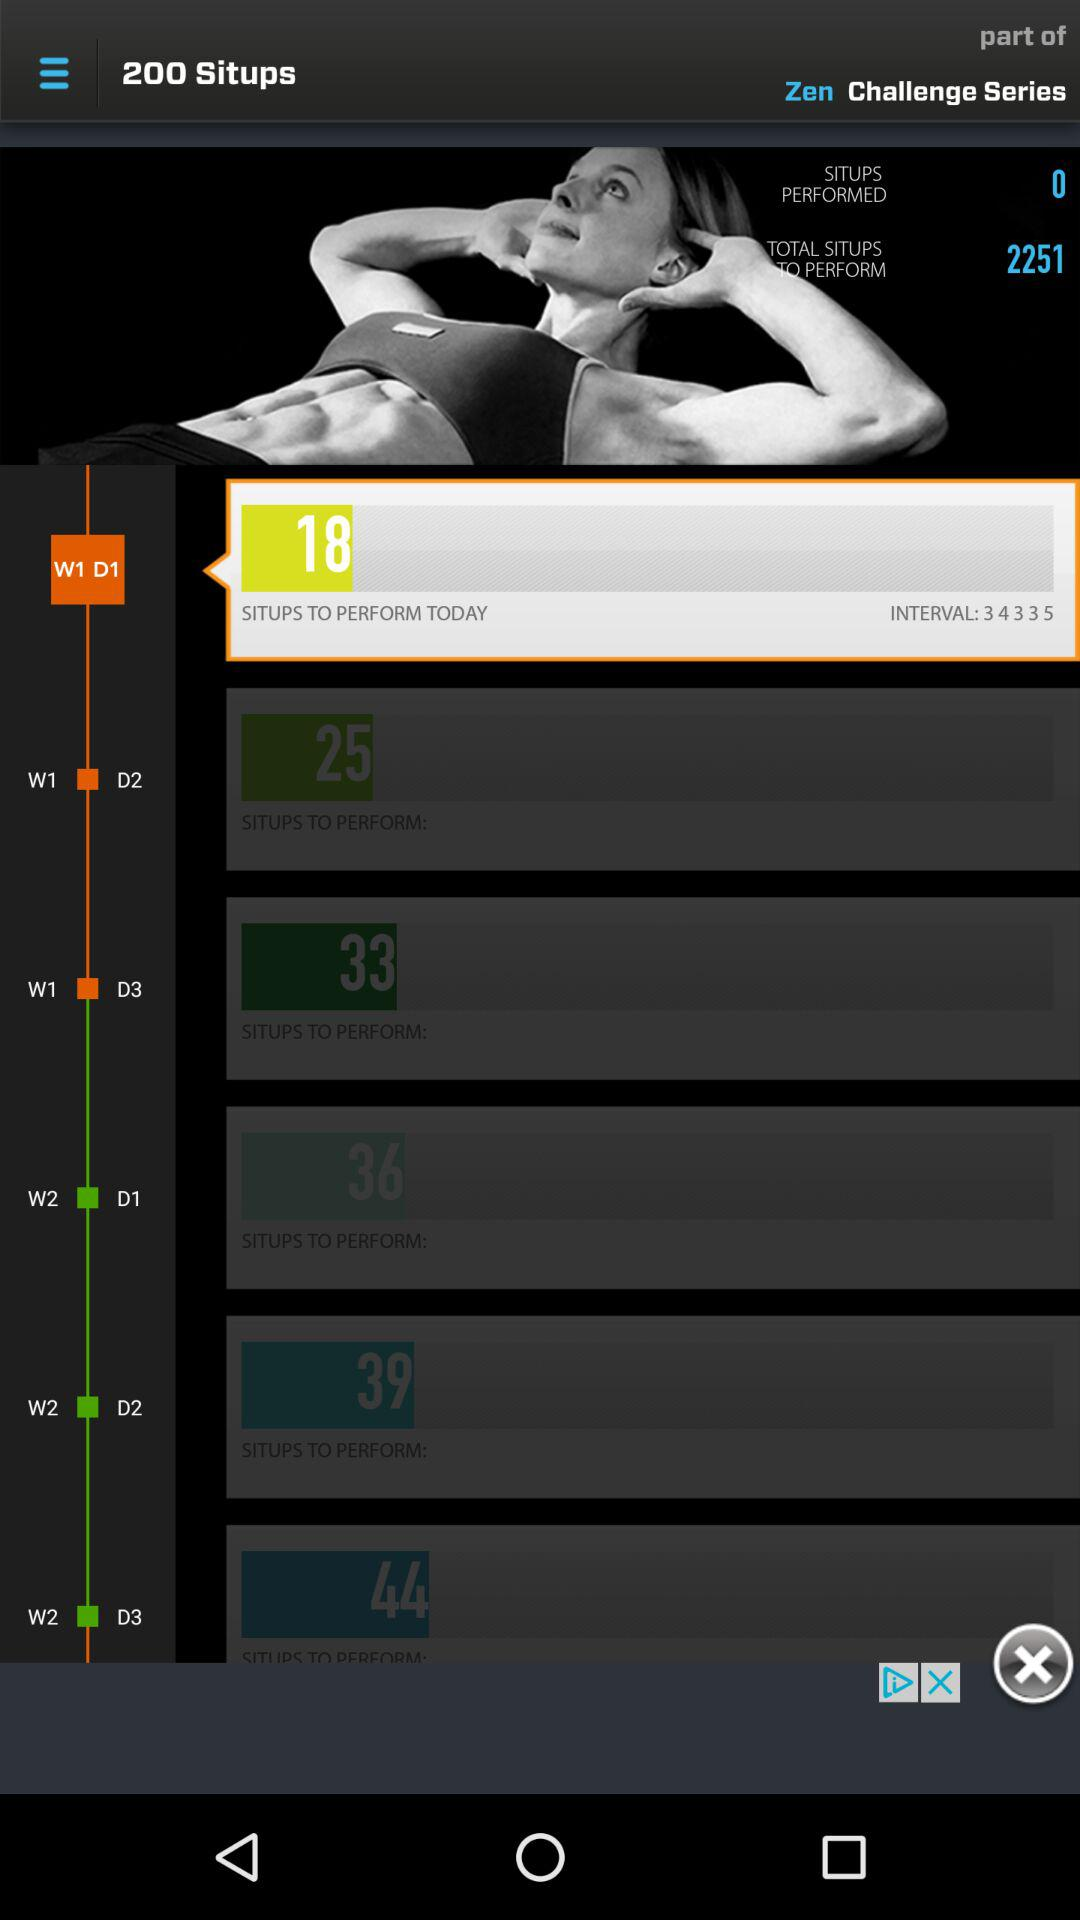How many total situps have to be performed? The total number of situps to be performed is 225. 